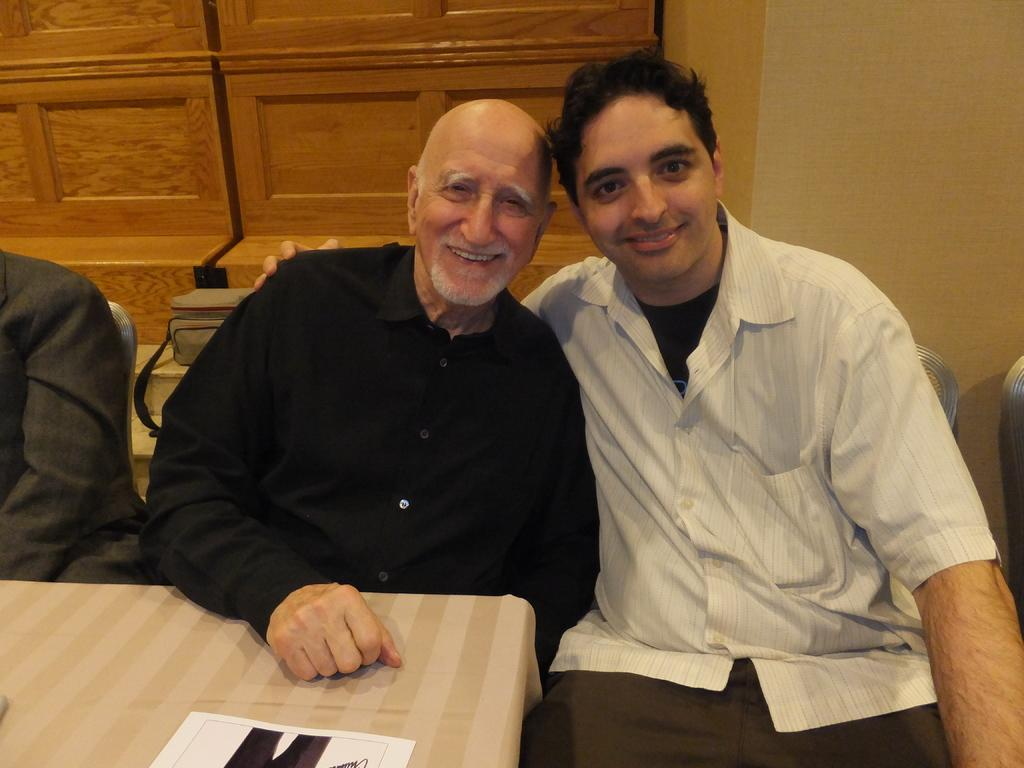Who or what is present in the image? There are people in the image. What are the people doing in the image? The people are sitting. What is the emotional expression of the people in the image? The people are smiling. What can be seen in the background of the image? There is a wall in the background of the image. What type of mitten is being used to lift the invention in the image? There is no mitten, lifting, or invention present in the image. 